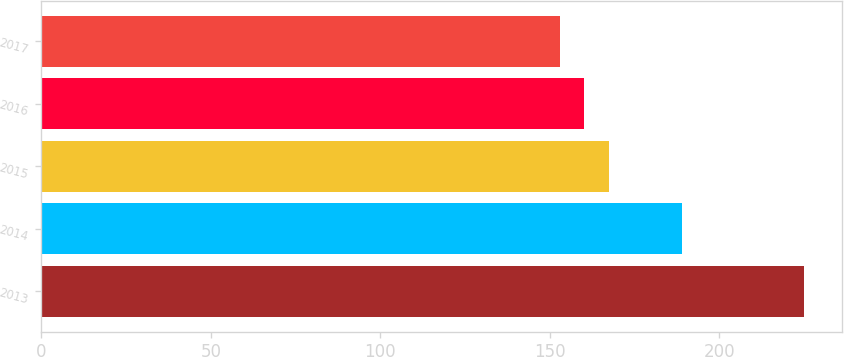Convert chart. <chart><loc_0><loc_0><loc_500><loc_500><bar_chart><fcel>2013<fcel>2014<fcel>2015<fcel>2016<fcel>2017<nl><fcel>225<fcel>189<fcel>167.4<fcel>160.2<fcel>153<nl></chart> 